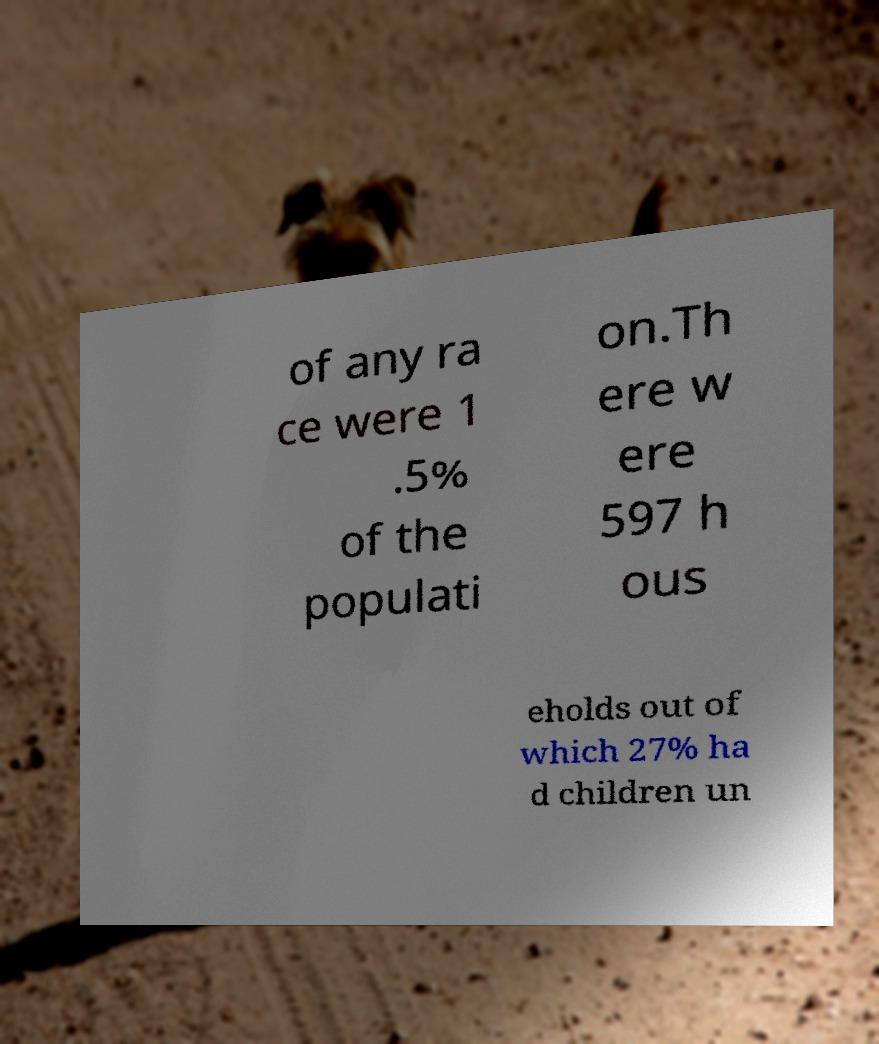Can you accurately transcribe the text from the provided image for me? of any ra ce were 1 .5% of the populati on.Th ere w ere 597 h ous eholds out of which 27% ha d children un 